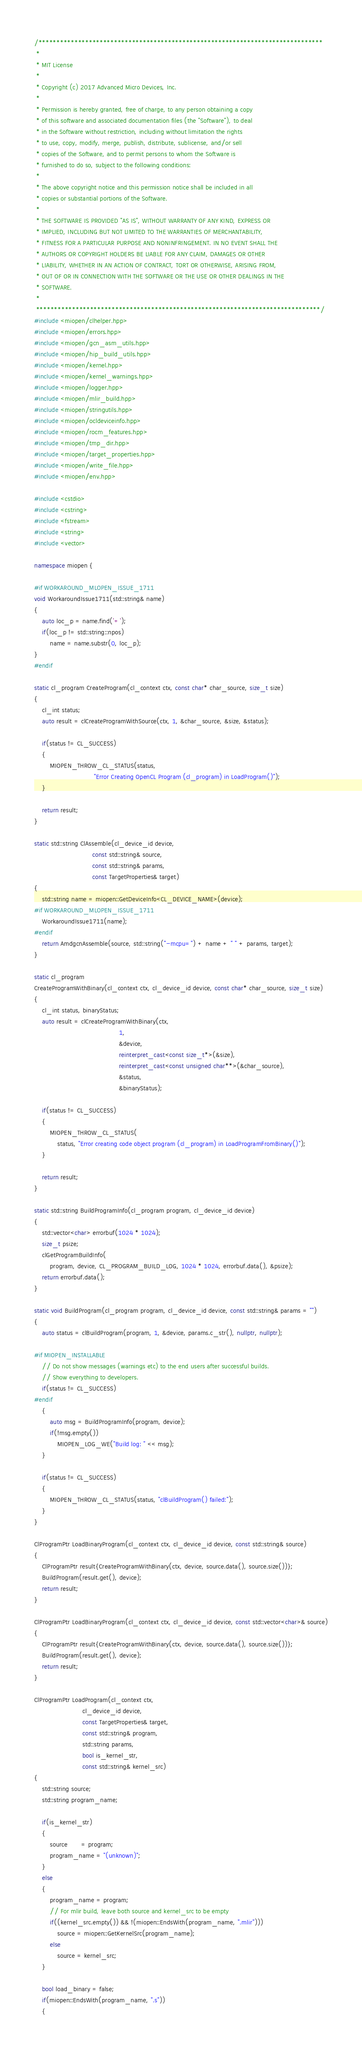<code> <loc_0><loc_0><loc_500><loc_500><_C++_>/*******************************************************************************
 *
 * MIT License
 *
 * Copyright (c) 2017 Advanced Micro Devices, Inc.
 *
 * Permission is hereby granted, free of charge, to any person obtaining a copy
 * of this software and associated documentation files (the "Software"), to deal
 * in the Software without restriction, including without limitation the rights
 * to use, copy, modify, merge, publish, distribute, sublicense, and/or sell
 * copies of the Software, and to permit persons to whom the Software is
 * furnished to do so, subject to the following conditions:
 *
 * The above copyright notice and this permission notice shall be included in all
 * copies or substantial portions of the Software.
 *
 * THE SOFTWARE IS PROVIDED "AS IS", WITHOUT WARRANTY OF ANY KIND, EXPRESS OR
 * IMPLIED, INCLUDING BUT NOT LIMITED TO THE WARRANTIES OF MERCHANTABILITY,
 * FITNESS FOR A PARTICULAR PURPOSE AND NONINFRINGEMENT. IN NO EVENT SHALL THE
 * AUTHORS OR COPYRIGHT HOLDERS BE LIABLE FOR ANY CLAIM, DAMAGES OR OTHER
 * LIABILITY, WHETHER IN AN ACTION OF CONTRACT, TORT OR OTHERWISE, ARISING FROM,
 * OUT OF OR IN CONNECTION WITH THE SOFTWARE OR THE USE OR OTHER DEALINGS IN THE
 * SOFTWARE.
 *
 *******************************************************************************/
#include <miopen/clhelper.hpp>
#include <miopen/errors.hpp>
#include <miopen/gcn_asm_utils.hpp>
#include <miopen/hip_build_utils.hpp>
#include <miopen/kernel.hpp>
#include <miopen/kernel_warnings.hpp>
#include <miopen/logger.hpp>
#include <miopen/mlir_build.hpp>
#include <miopen/stringutils.hpp>
#include <miopen/ocldeviceinfo.hpp>
#include <miopen/rocm_features.hpp>
#include <miopen/tmp_dir.hpp>
#include <miopen/target_properties.hpp>
#include <miopen/write_file.hpp>
#include <miopen/env.hpp>

#include <cstdio>
#include <cstring>
#include <fstream>
#include <string>
#include <vector>

namespace miopen {

#if WORKAROUND_MLOPEN_ISSUE_1711
void WorkaroundIssue1711(std::string& name)
{
    auto loc_p = name.find('+');
    if(loc_p != std::string::npos)
        name = name.substr(0, loc_p);
}
#endif

static cl_program CreateProgram(cl_context ctx, const char* char_source, size_t size)
{
    cl_int status;
    auto result = clCreateProgramWithSource(ctx, 1, &char_source, &size, &status);

    if(status != CL_SUCCESS)
    {
        MIOPEN_THROW_CL_STATUS(status,
                               "Error Creating OpenCL Program (cl_program) in LoadProgram()");
    }

    return result;
}

static std::string ClAssemble(cl_device_id device,
                              const std::string& source,
                              const std::string& params,
                              const TargetProperties& target)
{
    std::string name = miopen::GetDeviceInfo<CL_DEVICE_NAME>(device);
#if WORKAROUND_MLOPEN_ISSUE_1711
    WorkaroundIssue1711(name);
#endif
    return AmdgcnAssemble(source, std::string("-mcpu=") + name + " " + params, target);
}

static cl_program
CreateProgramWithBinary(cl_context ctx, cl_device_id device, const char* char_source, size_t size)
{
    cl_int status, binaryStatus;
    auto result = clCreateProgramWithBinary(ctx,
                                            1,
                                            &device,
                                            reinterpret_cast<const size_t*>(&size),
                                            reinterpret_cast<const unsigned char**>(&char_source),
                                            &status,
                                            &binaryStatus);

    if(status != CL_SUCCESS)
    {
        MIOPEN_THROW_CL_STATUS(
            status, "Error creating code object program (cl_program) in LoadProgramFromBinary()");
    }

    return result;
}

static std::string BuildProgramInfo(cl_program program, cl_device_id device)
{
    std::vector<char> errorbuf(1024 * 1024);
    size_t psize;
    clGetProgramBuildInfo(
        program, device, CL_PROGRAM_BUILD_LOG, 1024 * 1024, errorbuf.data(), &psize);
    return errorbuf.data();
}

static void BuildProgram(cl_program program, cl_device_id device, const std::string& params = "")
{
    auto status = clBuildProgram(program, 1, &device, params.c_str(), nullptr, nullptr);

#if MIOPEN_INSTALLABLE
    // Do not show messages (warnings etc) to the end users after successful builds.
    // Show everything to developers.
    if(status != CL_SUCCESS)
#endif
    {
        auto msg = BuildProgramInfo(program, device);
        if(!msg.empty())
            MIOPEN_LOG_WE("Build log: " << msg);
    }

    if(status != CL_SUCCESS)
    {
        MIOPEN_THROW_CL_STATUS(status, "clBuildProgram() failed:");
    }
}

ClProgramPtr LoadBinaryProgram(cl_context ctx, cl_device_id device, const std::string& source)
{
    ClProgramPtr result{CreateProgramWithBinary(ctx, device, source.data(), source.size())};
    BuildProgram(result.get(), device);
    return result;
}

ClProgramPtr LoadBinaryProgram(cl_context ctx, cl_device_id device, const std::vector<char>& source)
{
    ClProgramPtr result{CreateProgramWithBinary(ctx, device, source.data(), source.size())};
    BuildProgram(result.get(), device);
    return result;
}

ClProgramPtr LoadProgram(cl_context ctx,
                         cl_device_id device,
                         const TargetProperties& target,
                         const std::string& program,
                         std::string params,
                         bool is_kernel_str,
                         const std::string& kernel_src)
{
    std::string source;
    std::string program_name;

    if(is_kernel_str)
    {
        source       = program;
        program_name = "(unknown)";
    }
    else
    {
        program_name = program;
        // For mlir build, leave both source and kernel_src to be empty
        if((kernel_src.empty()) && !(miopen::EndsWith(program_name, ".mlir")))
            source = miopen::GetKernelSrc(program_name);
        else
            source = kernel_src;
    }

    bool load_binary = false;
    if(miopen::EndsWith(program_name, ".s"))
    {</code> 